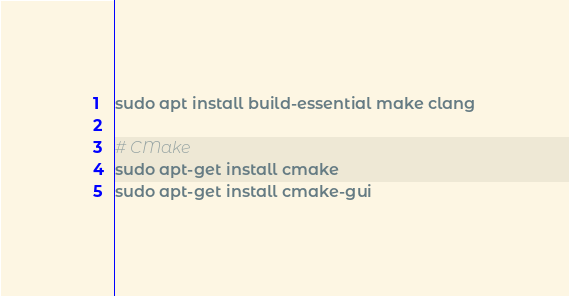<code> <loc_0><loc_0><loc_500><loc_500><_Bash_>sudo apt install build-essential make clang

# CMake
sudo apt-get install cmake
sudo apt-get install cmake-gui
</code> 